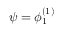Convert formula to latex. <formula><loc_0><loc_0><loc_500><loc_500>\psi = \phi _ { 1 } ^ { ( 1 ) }</formula> 